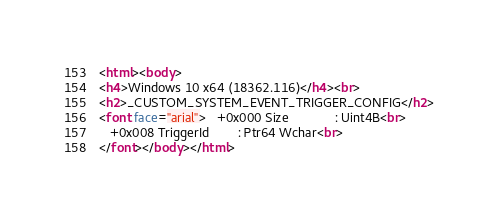<code> <loc_0><loc_0><loc_500><loc_500><_HTML_><html><body>
<h4>Windows 10 x64 (18362.116)</h4><br>
<h2>_CUSTOM_SYSTEM_EVENT_TRIGGER_CONFIG</h2>
<font face="arial">   +0x000 Size             : Uint4B<br>
   +0x008 TriggerId        : Ptr64 Wchar<br>
</font></body></html></code> 